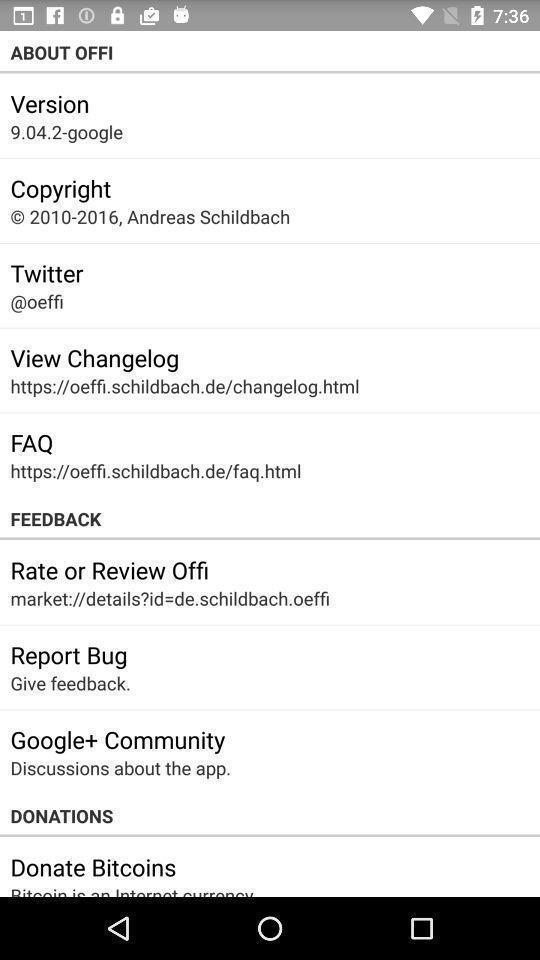Provide a textual representation of this image. Page displaying version. 